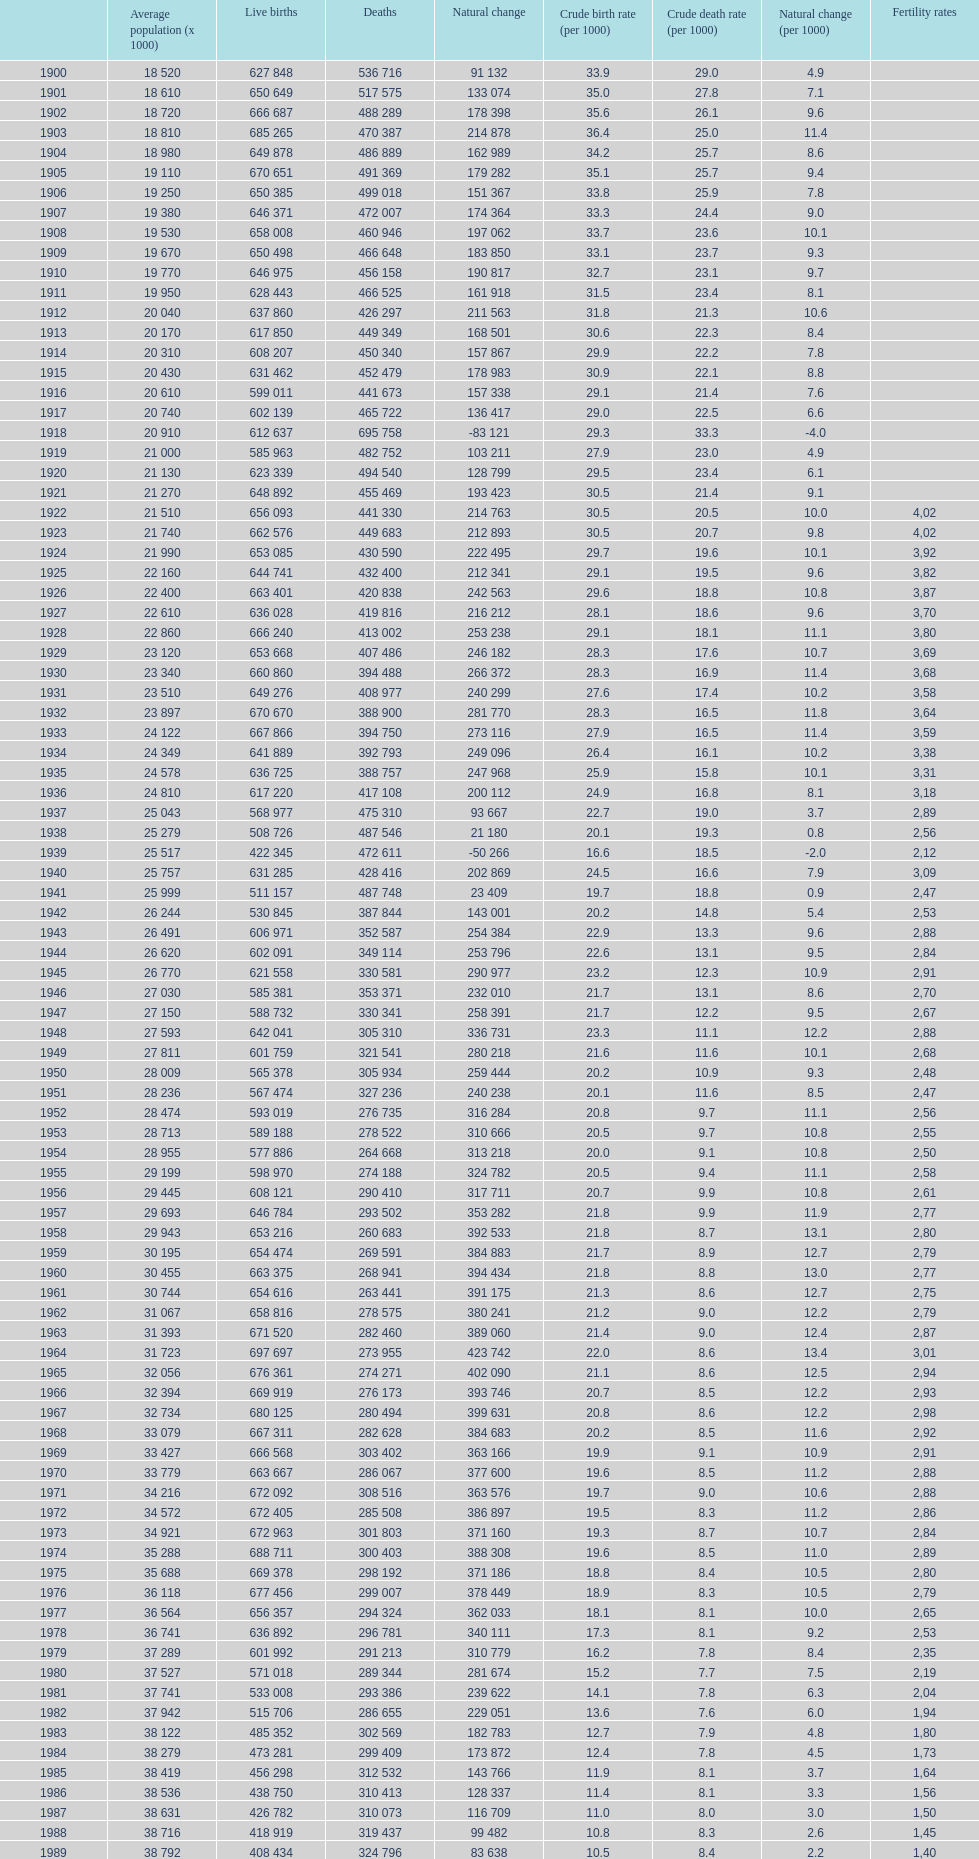In what year was the crude birth rate 2 1928. 